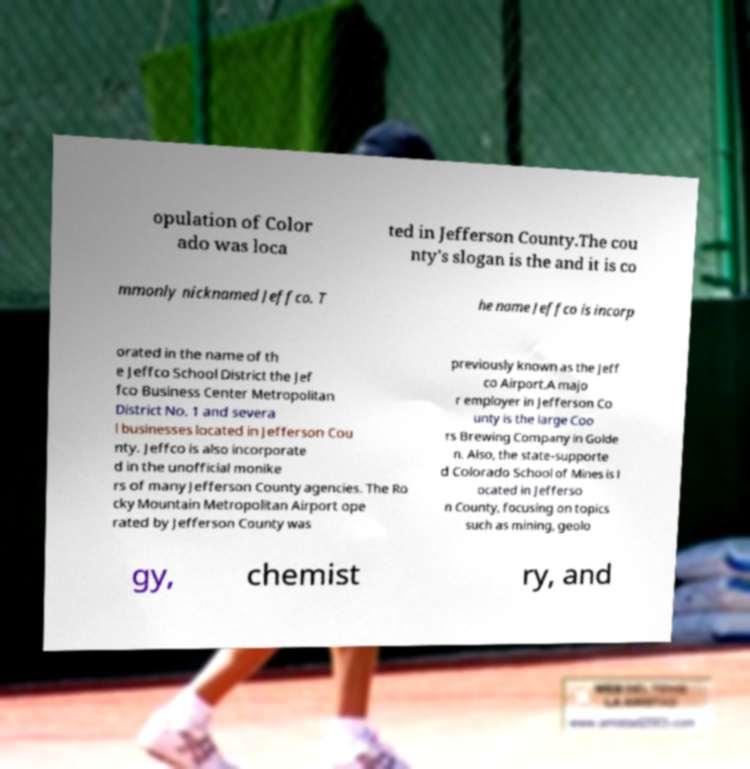Could you extract and type out the text from this image? opulation of Color ado was loca ted in Jefferson County.The cou nty's slogan is the and it is co mmonly nicknamed Jeffco. T he name Jeffco is incorp orated in the name of th e Jeffco School District the Jef fco Business Center Metropolitan District No. 1 and severa l businesses located in Jefferson Cou nty. Jeffco is also incorporate d in the unofficial monike rs of many Jefferson County agencies. The Ro cky Mountain Metropolitan Airport ope rated by Jefferson County was previously known as the Jeff co Airport.A majo r employer in Jefferson Co unty is the large Coo rs Brewing Company in Golde n. Also, the state-supporte d Colorado School of Mines is l ocated in Jefferso n County, focusing on topics such as mining, geolo gy, chemist ry, and 